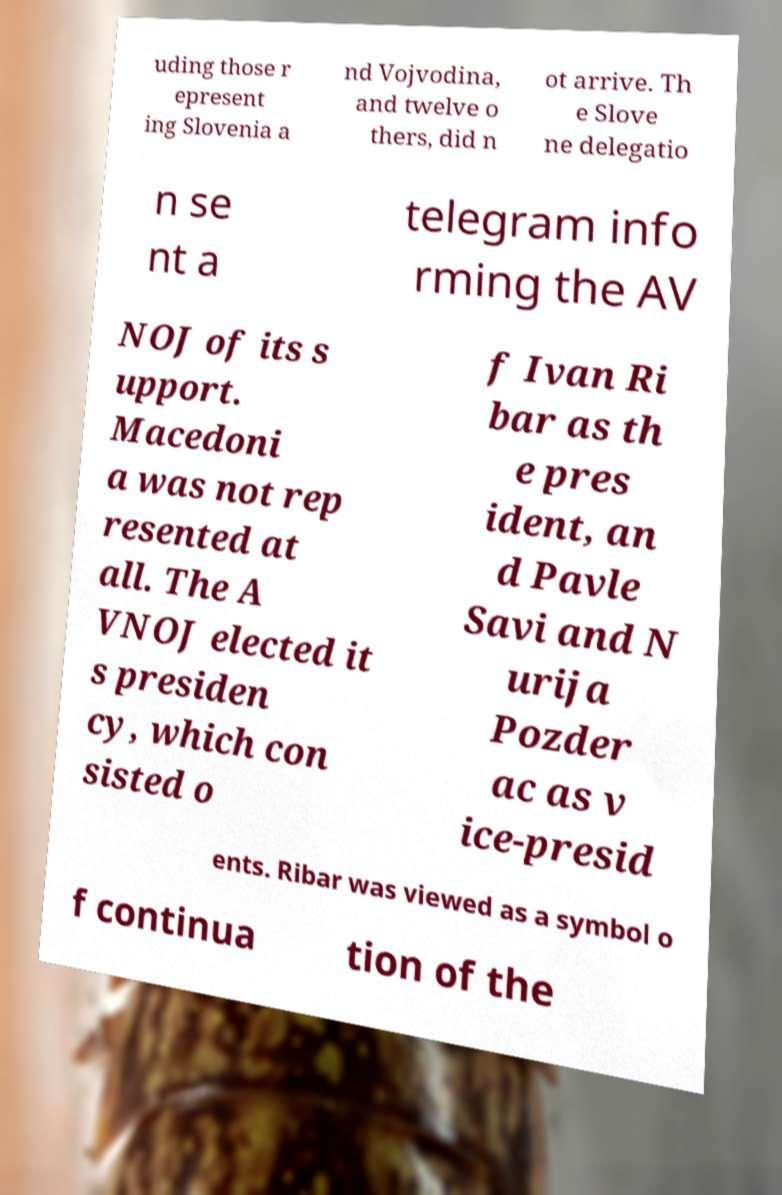Could you extract and type out the text from this image? uding those r epresent ing Slovenia a nd Vojvodina, and twelve o thers, did n ot arrive. Th e Slove ne delegatio n se nt a telegram info rming the AV NOJ of its s upport. Macedoni a was not rep resented at all. The A VNOJ elected it s presiden cy, which con sisted o f Ivan Ri bar as th e pres ident, an d Pavle Savi and N urija Pozder ac as v ice-presid ents. Ribar was viewed as a symbol o f continua tion of the 